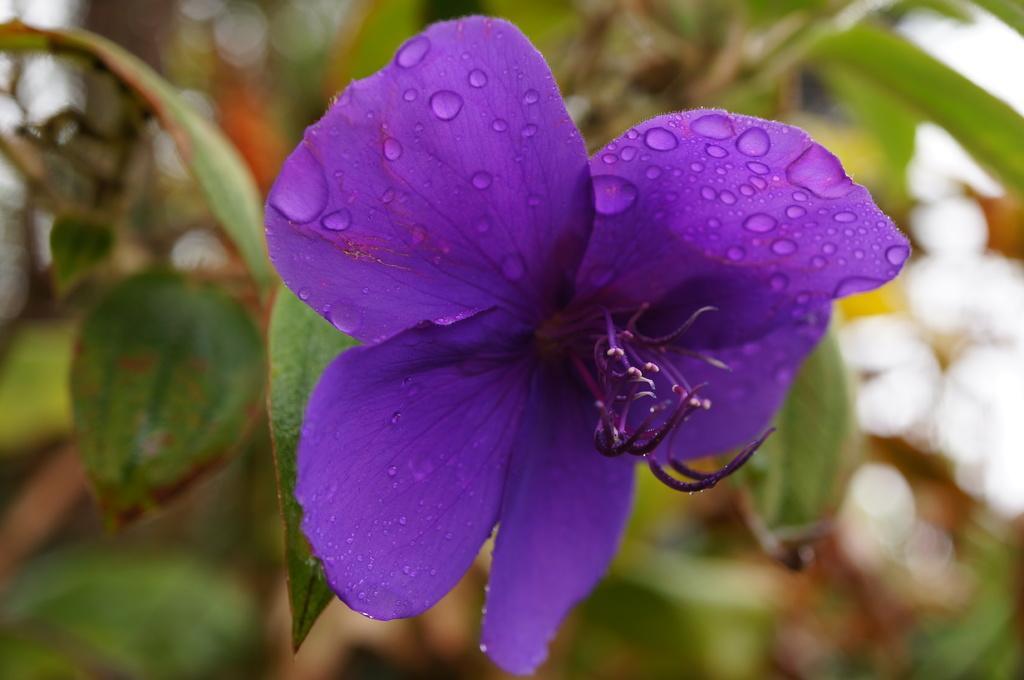How would you summarize this image in a sentence or two? In this image, we can see a plant with a flower. We can also see the blurred background. 